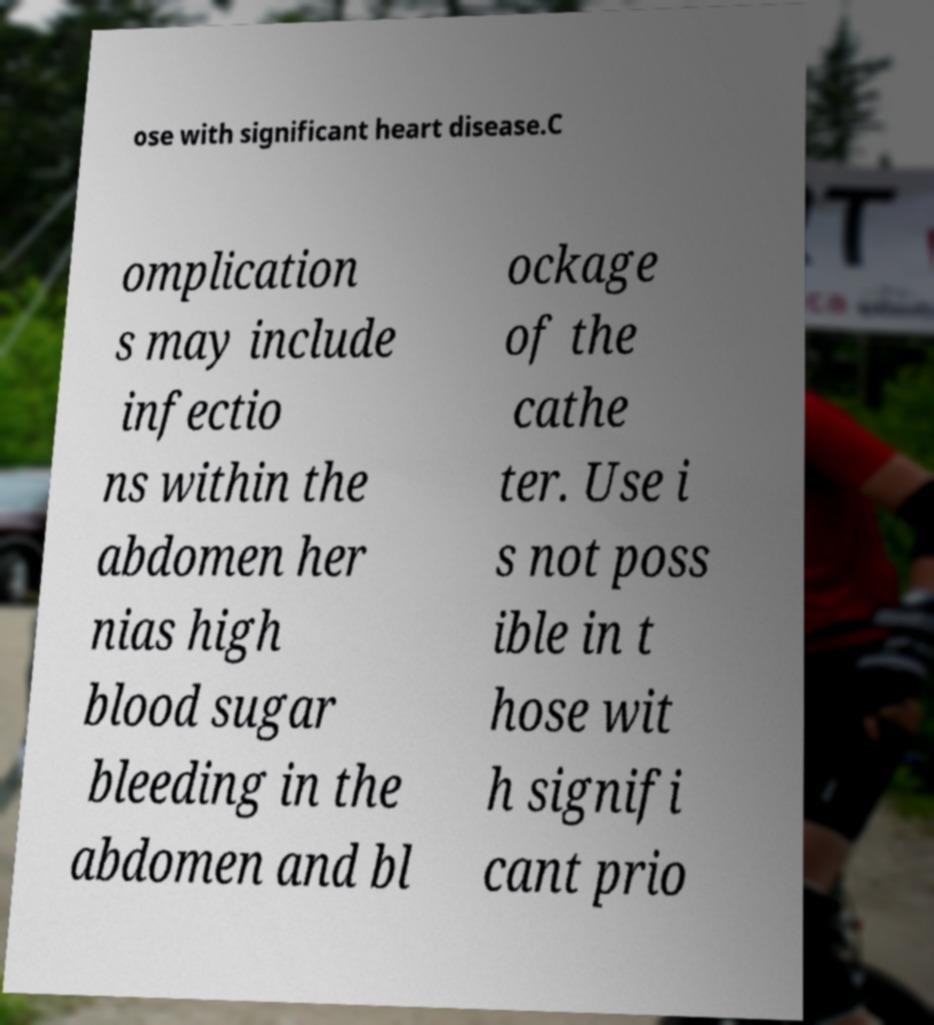I need the written content from this picture converted into text. Can you do that? ose with significant heart disease.C omplication s may include infectio ns within the abdomen her nias high blood sugar bleeding in the abdomen and bl ockage of the cathe ter. Use i s not poss ible in t hose wit h signifi cant prio 